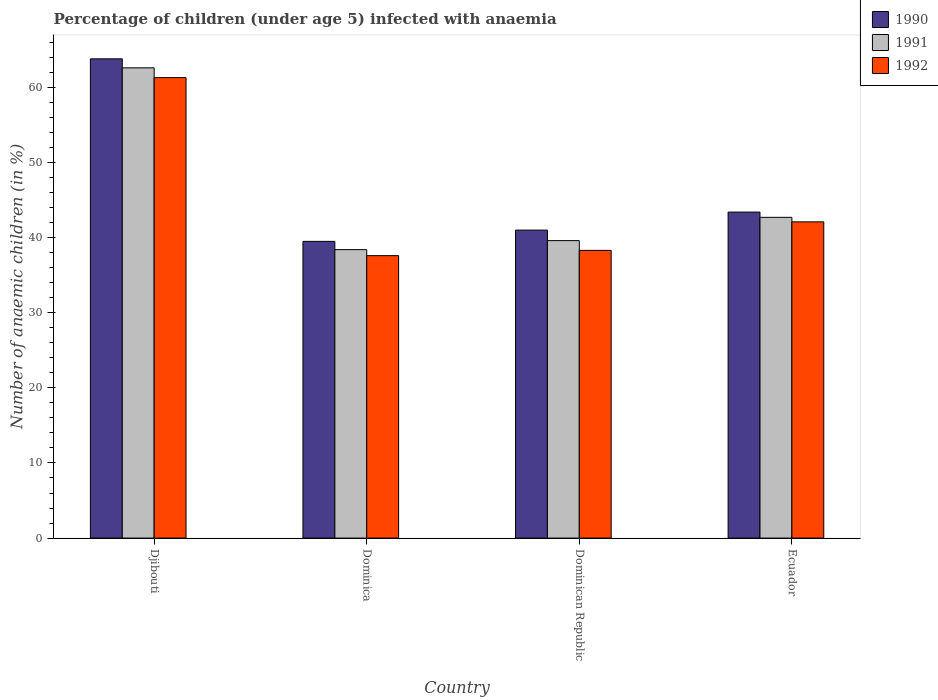How many different coloured bars are there?
Ensure brevity in your answer.  3. How many groups of bars are there?
Offer a terse response. 4. Are the number of bars per tick equal to the number of legend labels?
Your answer should be very brief. Yes. How many bars are there on the 3rd tick from the left?
Ensure brevity in your answer.  3. What is the label of the 2nd group of bars from the left?
Your answer should be compact. Dominica. What is the percentage of children infected with anaemia in in 1990 in Dominica?
Make the answer very short. 39.5. Across all countries, what is the maximum percentage of children infected with anaemia in in 1990?
Offer a very short reply. 63.8. Across all countries, what is the minimum percentage of children infected with anaemia in in 1991?
Provide a succinct answer. 38.4. In which country was the percentage of children infected with anaemia in in 1992 maximum?
Offer a very short reply. Djibouti. In which country was the percentage of children infected with anaemia in in 1991 minimum?
Your response must be concise. Dominica. What is the total percentage of children infected with anaemia in in 1992 in the graph?
Your answer should be very brief. 179.3. What is the difference between the percentage of children infected with anaemia in in 1992 in Djibouti and the percentage of children infected with anaemia in in 1990 in Dominica?
Your response must be concise. 21.8. What is the average percentage of children infected with anaemia in in 1991 per country?
Your answer should be compact. 45.83. What is the difference between the percentage of children infected with anaemia in of/in 1992 and percentage of children infected with anaemia in of/in 1991 in Djibouti?
Your answer should be compact. -1.3. In how many countries, is the percentage of children infected with anaemia in in 1991 greater than 8 %?
Your response must be concise. 4. What is the ratio of the percentage of children infected with anaemia in in 1992 in Djibouti to that in Ecuador?
Your response must be concise. 1.46. Is the difference between the percentage of children infected with anaemia in in 1992 in Djibouti and Dominica greater than the difference between the percentage of children infected with anaemia in in 1991 in Djibouti and Dominica?
Your answer should be compact. No. What is the difference between the highest and the second highest percentage of children infected with anaemia in in 1991?
Your response must be concise. -19.9. What is the difference between the highest and the lowest percentage of children infected with anaemia in in 1992?
Give a very brief answer. 23.7. Is the sum of the percentage of children infected with anaemia in in 1992 in Djibouti and Dominica greater than the maximum percentage of children infected with anaemia in in 1990 across all countries?
Keep it short and to the point. Yes. How many bars are there?
Your answer should be very brief. 12. Are all the bars in the graph horizontal?
Provide a short and direct response. No. Are the values on the major ticks of Y-axis written in scientific E-notation?
Your answer should be compact. No. Does the graph contain any zero values?
Your response must be concise. No. Where does the legend appear in the graph?
Keep it short and to the point. Top right. How many legend labels are there?
Your answer should be compact. 3. What is the title of the graph?
Ensure brevity in your answer.  Percentage of children (under age 5) infected with anaemia. What is the label or title of the X-axis?
Your answer should be very brief. Country. What is the label or title of the Y-axis?
Give a very brief answer. Number of anaemic children (in %). What is the Number of anaemic children (in %) of 1990 in Djibouti?
Offer a terse response. 63.8. What is the Number of anaemic children (in %) of 1991 in Djibouti?
Keep it short and to the point. 62.6. What is the Number of anaemic children (in %) in 1992 in Djibouti?
Your answer should be very brief. 61.3. What is the Number of anaemic children (in %) of 1990 in Dominica?
Offer a very short reply. 39.5. What is the Number of anaemic children (in %) in 1991 in Dominica?
Provide a short and direct response. 38.4. What is the Number of anaemic children (in %) in 1992 in Dominica?
Your response must be concise. 37.6. What is the Number of anaemic children (in %) of 1991 in Dominican Republic?
Give a very brief answer. 39.6. What is the Number of anaemic children (in %) of 1992 in Dominican Republic?
Your answer should be very brief. 38.3. What is the Number of anaemic children (in %) in 1990 in Ecuador?
Ensure brevity in your answer.  43.4. What is the Number of anaemic children (in %) in 1991 in Ecuador?
Provide a short and direct response. 42.7. What is the Number of anaemic children (in %) of 1992 in Ecuador?
Offer a very short reply. 42.1. Across all countries, what is the maximum Number of anaemic children (in %) of 1990?
Give a very brief answer. 63.8. Across all countries, what is the maximum Number of anaemic children (in %) of 1991?
Keep it short and to the point. 62.6. Across all countries, what is the maximum Number of anaemic children (in %) in 1992?
Provide a short and direct response. 61.3. Across all countries, what is the minimum Number of anaemic children (in %) in 1990?
Provide a succinct answer. 39.5. Across all countries, what is the minimum Number of anaemic children (in %) of 1991?
Your response must be concise. 38.4. Across all countries, what is the minimum Number of anaemic children (in %) of 1992?
Your response must be concise. 37.6. What is the total Number of anaemic children (in %) of 1990 in the graph?
Provide a short and direct response. 187.7. What is the total Number of anaemic children (in %) in 1991 in the graph?
Offer a very short reply. 183.3. What is the total Number of anaemic children (in %) in 1992 in the graph?
Provide a succinct answer. 179.3. What is the difference between the Number of anaemic children (in %) of 1990 in Djibouti and that in Dominica?
Give a very brief answer. 24.3. What is the difference between the Number of anaemic children (in %) of 1991 in Djibouti and that in Dominica?
Give a very brief answer. 24.2. What is the difference between the Number of anaemic children (in %) in 1992 in Djibouti and that in Dominica?
Your response must be concise. 23.7. What is the difference between the Number of anaemic children (in %) in 1990 in Djibouti and that in Dominican Republic?
Make the answer very short. 22.8. What is the difference between the Number of anaemic children (in %) in 1990 in Djibouti and that in Ecuador?
Your response must be concise. 20.4. What is the difference between the Number of anaemic children (in %) in 1991 in Djibouti and that in Ecuador?
Make the answer very short. 19.9. What is the difference between the Number of anaemic children (in %) in 1990 in Dominica and that in Dominican Republic?
Offer a terse response. -1.5. What is the difference between the Number of anaemic children (in %) of 1991 in Dominica and that in Dominican Republic?
Keep it short and to the point. -1.2. What is the difference between the Number of anaemic children (in %) of 1990 in Djibouti and the Number of anaemic children (in %) of 1991 in Dominica?
Ensure brevity in your answer.  25.4. What is the difference between the Number of anaemic children (in %) in 1990 in Djibouti and the Number of anaemic children (in %) in 1992 in Dominica?
Offer a terse response. 26.2. What is the difference between the Number of anaemic children (in %) of 1991 in Djibouti and the Number of anaemic children (in %) of 1992 in Dominica?
Offer a very short reply. 25. What is the difference between the Number of anaemic children (in %) in 1990 in Djibouti and the Number of anaemic children (in %) in 1991 in Dominican Republic?
Ensure brevity in your answer.  24.2. What is the difference between the Number of anaemic children (in %) of 1991 in Djibouti and the Number of anaemic children (in %) of 1992 in Dominican Republic?
Offer a very short reply. 24.3. What is the difference between the Number of anaemic children (in %) in 1990 in Djibouti and the Number of anaemic children (in %) in 1991 in Ecuador?
Offer a terse response. 21.1. What is the difference between the Number of anaemic children (in %) in 1990 in Djibouti and the Number of anaemic children (in %) in 1992 in Ecuador?
Keep it short and to the point. 21.7. What is the difference between the Number of anaemic children (in %) in 1991 in Djibouti and the Number of anaemic children (in %) in 1992 in Ecuador?
Make the answer very short. 20.5. What is the difference between the Number of anaemic children (in %) in 1991 in Dominica and the Number of anaemic children (in %) in 1992 in Dominican Republic?
Offer a terse response. 0.1. What is the difference between the Number of anaemic children (in %) in 1990 in Dominica and the Number of anaemic children (in %) in 1992 in Ecuador?
Your answer should be compact. -2.6. What is the difference between the Number of anaemic children (in %) of 1990 in Dominican Republic and the Number of anaemic children (in %) of 1991 in Ecuador?
Keep it short and to the point. -1.7. What is the average Number of anaemic children (in %) in 1990 per country?
Keep it short and to the point. 46.92. What is the average Number of anaemic children (in %) in 1991 per country?
Keep it short and to the point. 45.83. What is the average Number of anaemic children (in %) in 1992 per country?
Your answer should be very brief. 44.83. What is the difference between the Number of anaemic children (in %) in 1990 and Number of anaemic children (in %) in 1991 in Djibouti?
Give a very brief answer. 1.2. What is the difference between the Number of anaemic children (in %) of 1990 and Number of anaemic children (in %) of 1992 in Djibouti?
Your response must be concise. 2.5. What is the difference between the Number of anaemic children (in %) in 1991 and Number of anaemic children (in %) in 1992 in Djibouti?
Offer a very short reply. 1.3. What is the difference between the Number of anaemic children (in %) in 1990 and Number of anaemic children (in %) in 1992 in Dominica?
Make the answer very short. 1.9. What is the difference between the Number of anaemic children (in %) of 1990 and Number of anaemic children (in %) of 1992 in Ecuador?
Your answer should be very brief. 1.3. What is the difference between the Number of anaemic children (in %) in 1991 and Number of anaemic children (in %) in 1992 in Ecuador?
Ensure brevity in your answer.  0.6. What is the ratio of the Number of anaemic children (in %) in 1990 in Djibouti to that in Dominica?
Your answer should be very brief. 1.62. What is the ratio of the Number of anaemic children (in %) in 1991 in Djibouti to that in Dominica?
Keep it short and to the point. 1.63. What is the ratio of the Number of anaemic children (in %) of 1992 in Djibouti to that in Dominica?
Provide a succinct answer. 1.63. What is the ratio of the Number of anaemic children (in %) of 1990 in Djibouti to that in Dominican Republic?
Your answer should be very brief. 1.56. What is the ratio of the Number of anaemic children (in %) of 1991 in Djibouti to that in Dominican Republic?
Give a very brief answer. 1.58. What is the ratio of the Number of anaemic children (in %) in 1992 in Djibouti to that in Dominican Republic?
Keep it short and to the point. 1.6. What is the ratio of the Number of anaemic children (in %) in 1990 in Djibouti to that in Ecuador?
Your answer should be very brief. 1.47. What is the ratio of the Number of anaemic children (in %) in 1991 in Djibouti to that in Ecuador?
Give a very brief answer. 1.47. What is the ratio of the Number of anaemic children (in %) of 1992 in Djibouti to that in Ecuador?
Ensure brevity in your answer.  1.46. What is the ratio of the Number of anaemic children (in %) of 1990 in Dominica to that in Dominican Republic?
Your response must be concise. 0.96. What is the ratio of the Number of anaemic children (in %) of 1991 in Dominica to that in Dominican Republic?
Offer a terse response. 0.97. What is the ratio of the Number of anaemic children (in %) of 1992 in Dominica to that in Dominican Republic?
Provide a short and direct response. 0.98. What is the ratio of the Number of anaemic children (in %) in 1990 in Dominica to that in Ecuador?
Your answer should be compact. 0.91. What is the ratio of the Number of anaemic children (in %) in 1991 in Dominica to that in Ecuador?
Provide a short and direct response. 0.9. What is the ratio of the Number of anaemic children (in %) in 1992 in Dominica to that in Ecuador?
Your response must be concise. 0.89. What is the ratio of the Number of anaemic children (in %) of 1990 in Dominican Republic to that in Ecuador?
Keep it short and to the point. 0.94. What is the ratio of the Number of anaemic children (in %) in 1991 in Dominican Republic to that in Ecuador?
Ensure brevity in your answer.  0.93. What is the ratio of the Number of anaemic children (in %) of 1992 in Dominican Republic to that in Ecuador?
Your answer should be compact. 0.91. What is the difference between the highest and the second highest Number of anaemic children (in %) of 1990?
Your answer should be compact. 20.4. What is the difference between the highest and the second highest Number of anaemic children (in %) in 1991?
Make the answer very short. 19.9. What is the difference between the highest and the second highest Number of anaemic children (in %) in 1992?
Offer a very short reply. 19.2. What is the difference between the highest and the lowest Number of anaemic children (in %) of 1990?
Give a very brief answer. 24.3. What is the difference between the highest and the lowest Number of anaemic children (in %) in 1991?
Offer a terse response. 24.2. What is the difference between the highest and the lowest Number of anaemic children (in %) of 1992?
Provide a short and direct response. 23.7. 